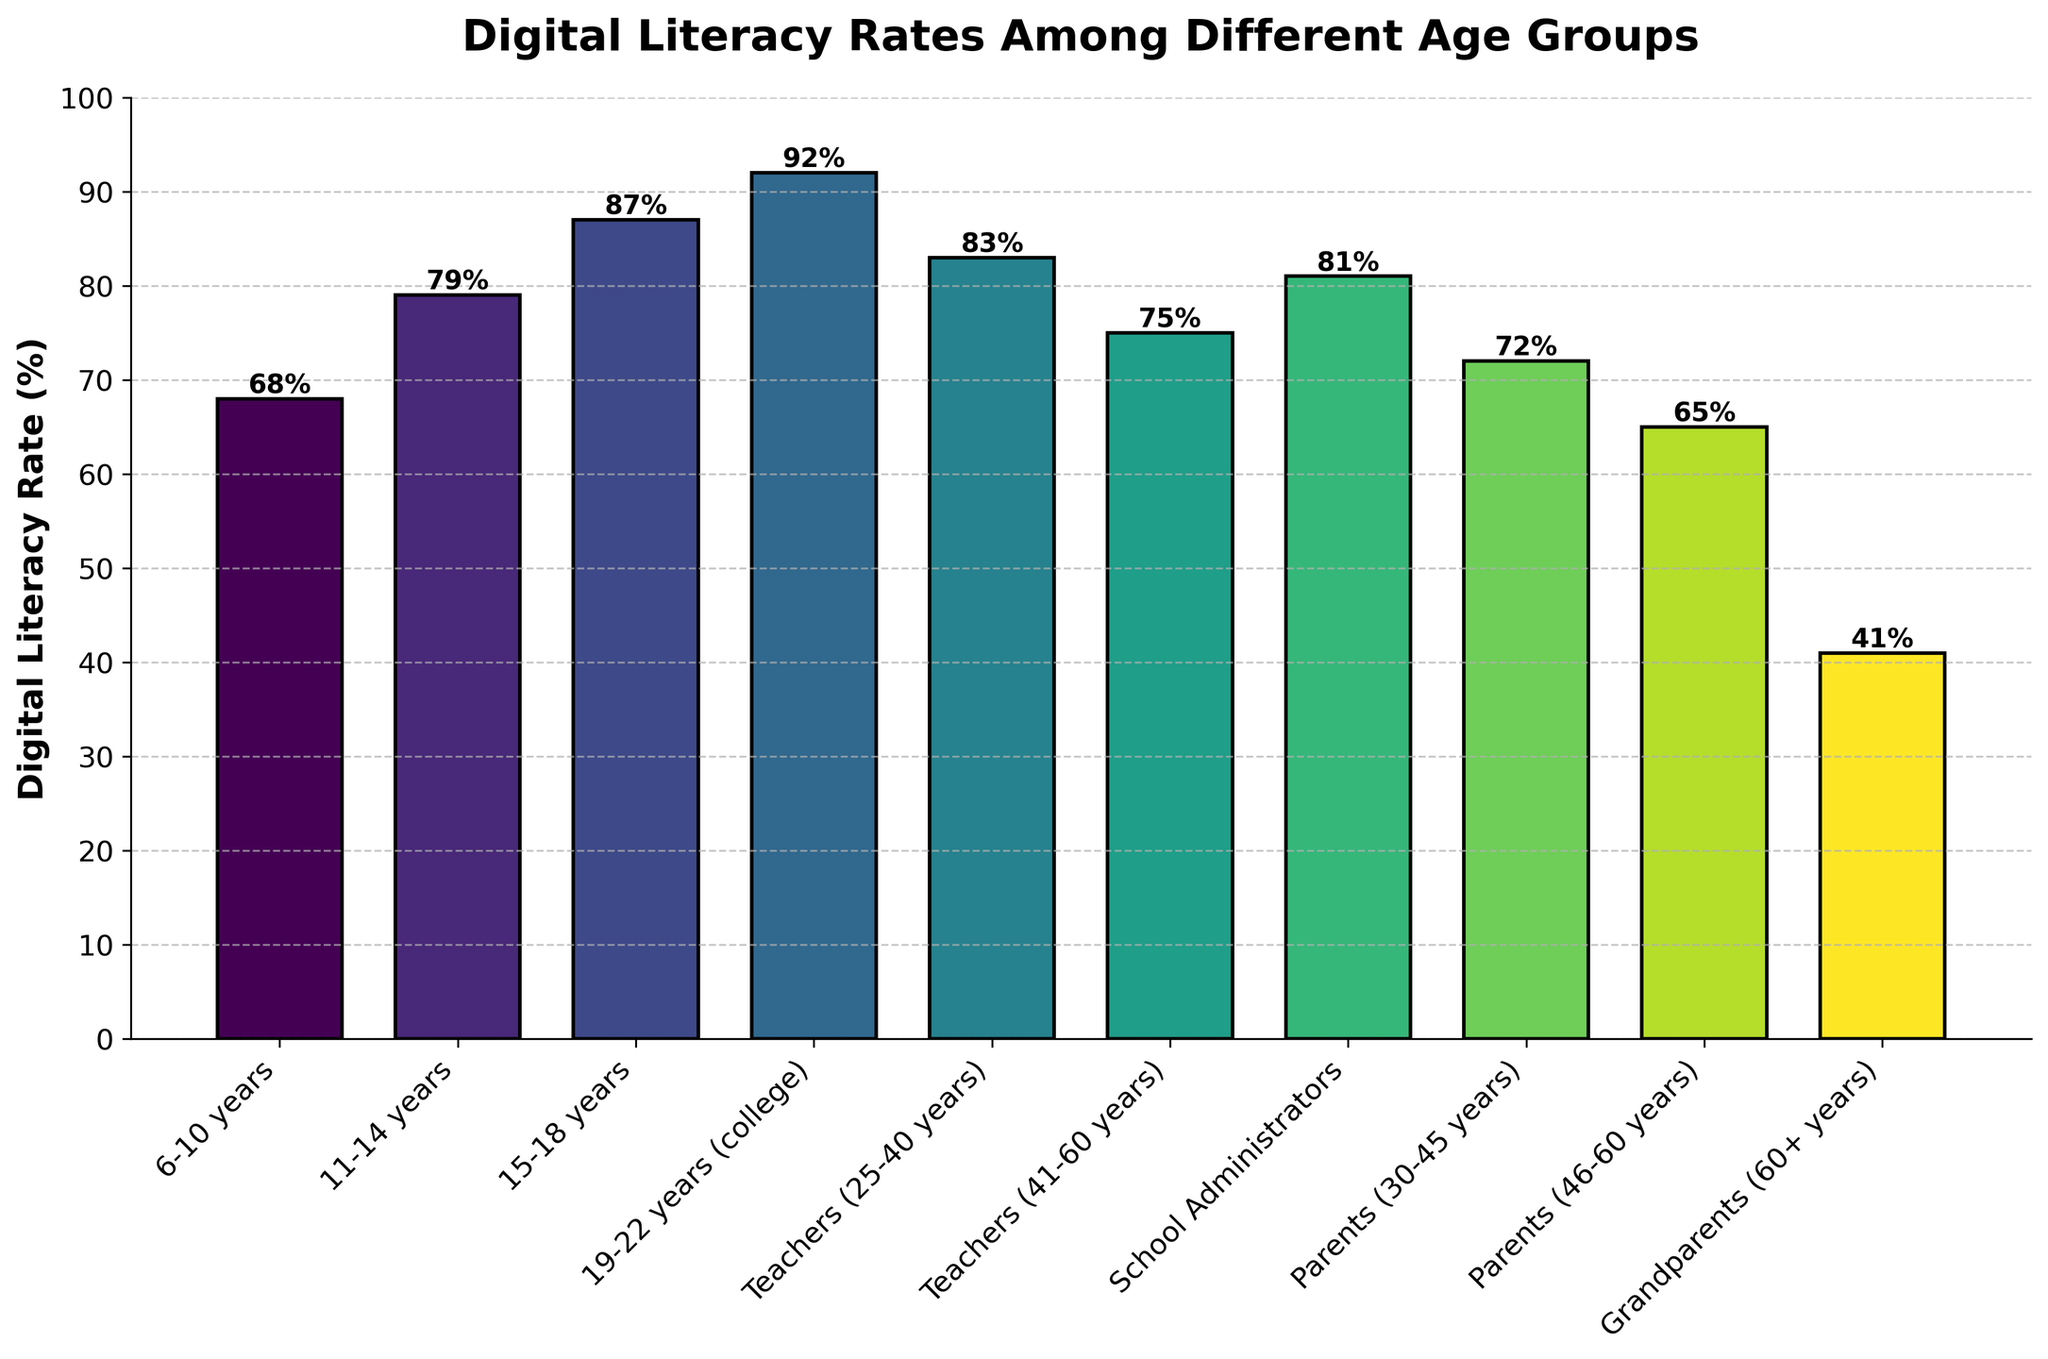Which age group has the highest digital literacy rate? The bar representing the 19-22 years (college) age group has the highest height, indicating the highest digital literacy rate at 92%.
Answer: 19-22 years (college) How does the digital literacy rate of Teachers (25-40 years) compare to Teachers (41-60 years)? The digital literacy rate for Teachers (25-40 years) is 83%, while for Teachers (41-60 years) it is 75%. Therefore, the rate for 25-40 years is higher by 8%.
Answer: Higher by 8% What is the difference in digital literacy rates between Parents (30-45 years) and Grandparents (60+ years)? The digital literacy rate for Parents (30-45 years) is 72%, and for Grandparents (60+ years) it is 41%. The difference is calculated as 72% - 41% = 31%.
Answer: 31% Which group has a higher digital literacy rate: School Administrators or Parents (30-45 years)? School Administrators have a digital literacy rate of 81%, while Parents (30-45 years) have a rate of 72%. Therefore, School Administrators have a higher rate.
Answer: School Administrators What is the average digital literacy rate for all age groups presented? Summing up the digital literacy rates: 68 + 79 + 87 + 92 + 83 + 75 + 81 + 72 + 65 + 41 = 743. Dividing by the 10 groups, the average rate is 743 / 10 = 74.3%.
Answer: 74.3% Which group has the lowest digital literacy rate, and what is the rate? The bar for Grandparents (60+ years) is the shortest, indicating the lowest digital literacy rate at 41%.
Answer: Grandparents (60+ years), 41% How many percentage points higher is the digital literacy rate of 15-18 years compared to 6-10 years? The digital literacy rate for 15-18 years is 87%, and for 6-10 years it is 68%. The difference is 87% - 68% = 19 percentage points.
Answer: 19 percentage points Does the digital literacy rate of Teachers (25-40 years) exceed the average digital literacy rate of all age groups? The average digital literacy rate for all groups is 74.3%. Teachers (25-40 years) have a rate of 83%, which exceeds the average rate.
Answer: Yes 